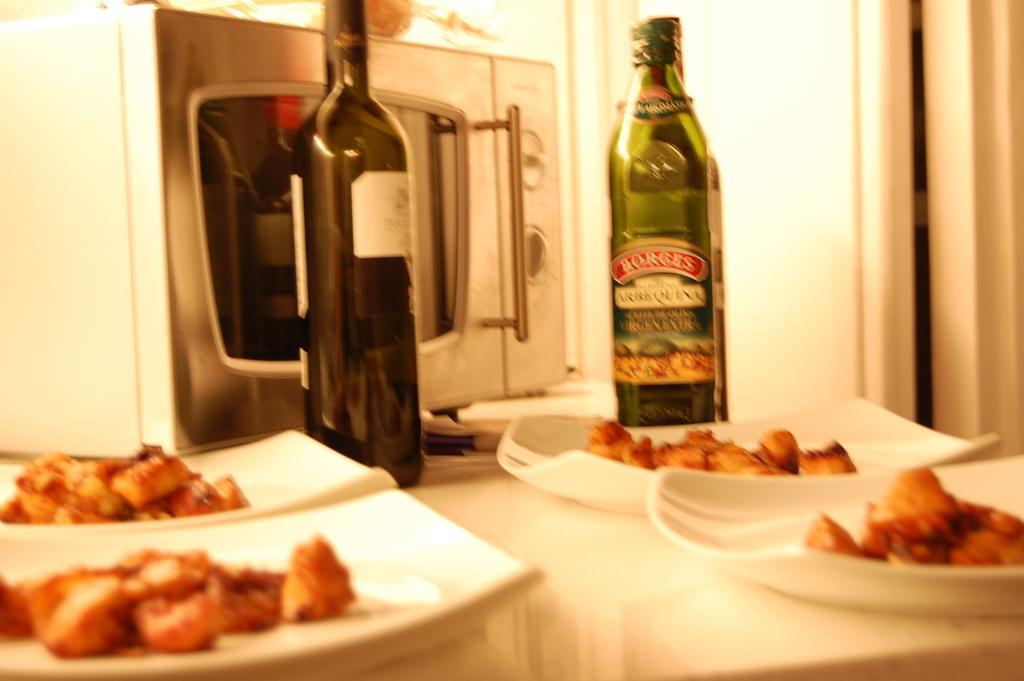Could you give a brief overview of what you see in this image? There are two wine bottles,a micro oven and some eatables placed on a table. 